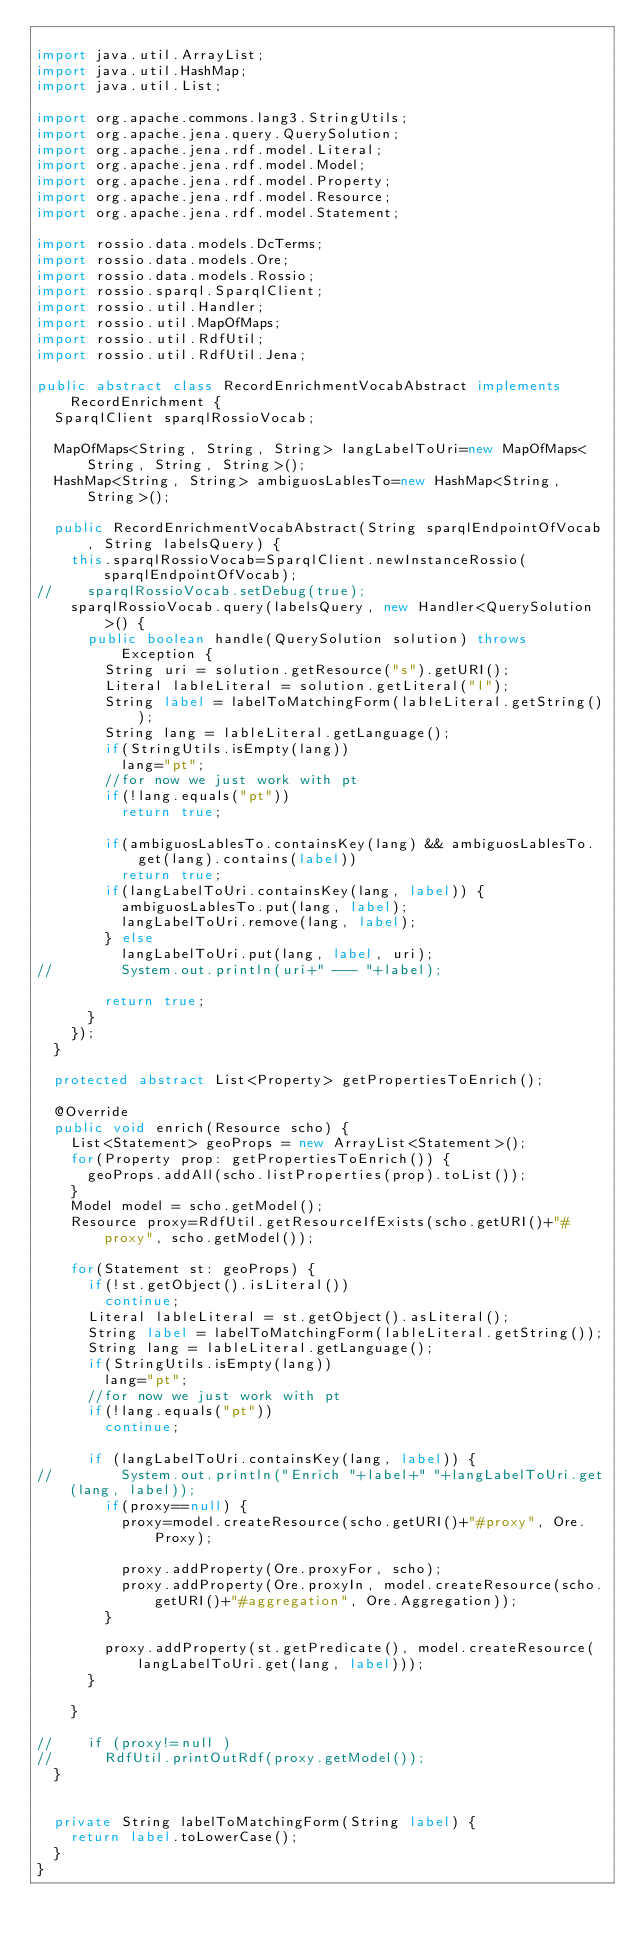<code> <loc_0><loc_0><loc_500><loc_500><_Java_>
import java.util.ArrayList;
import java.util.HashMap;
import java.util.List;

import org.apache.commons.lang3.StringUtils;
import org.apache.jena.query.QuerySolution;
import org.apache.jena.rdf.model.Literal;
import org.apache.jena.rdf.model.Model;
import org.apache.jena.rdf.model.Property;
import org.apache.jena.rdf.model.Resource;
import org.apache.jena.rdf.model.Statement;

import rossio.data.models.DcTerms;
import rossio.data.models.Ore;
import rossio.data.models.Rossio;
import rossio.sparql.SparqlClient;
import rossio.util.Handler;
import rossio.util.MapOfMaps;
import rossio.util.RdfUtil;
import rossio.util.RdfUtil.Jena;

public abstract class RecordEnrichmentVocabAbstract implements RecordEnrichment {
	SparqlClient sparqlRossioVocab;
	
	MapOfMaps<String, String, String> langLabelToUri=new MapOfMaps<String, String, String>();
	HashMap<String, String> ambiguosLablesTo=new HashMap<String, String>();
	
	public RecordEnrichmentVocabAbstract(String sparqlEndpointOfVocab, String labelsQuery) {
		this.sparqlRossioVocab=SparqlClient.newInstanceRossio(sparqlEndpointOfVocab);
//		sparqlRossioVocab.setDebug(true);
		sparqlRossioVocab.query(labelsQuery, new Handler<QuerySolution>() {
			public boolean handle(QuerySolution solution) throws Exception {
				String uri = solution.getResource("s").getURI();
				Literal lableLiteral = solution.getLiteral("l");
				String label = labelToMatchingForm(lableLiteral.getString());
				String lang = lableLiteral.getLanguage();
				if(StringUtils.isEmpty(lang))
					lang="pt";
				//for now we just work with pt
				if(!lang.equals("pt"))
					return true;
				
				if(ambiguosLablesTo.containsKey(lang) && ambiguosLablesTo.get(lang).contains(label))
					return true;
				if(langLabelToUri.containsKey(lang, label)) {
					ambiguosLablesTo.put(lang, label);
					langLabelToUri.remove(lang, label);
				} else
					langLabelToUri.put(lang, label, uri);
//				System.out.println(uri+" --- "+label);
				
				return true;
			}
		});
	}
	
	protected abstract List<Property> getPropertiesToEnrich();
	
	@Override
	public void enrich(Resource scho) {
		List<Statement> geoProps = new ArrayList<Statement>();
		for(Property prop: getPropertiesToEnrich()) {
			geoProps.addAll(scho.listProperties(prop).toList());			
		}
		Model model = scho.getModel();
		Resource proxy=RdfUtil.getResourceIfExists(scho.getURI()+"#proxy", scho.getModel());
		
		for(Statement st: geoProps) {
			if(!st.getObject().isLiteral())
				continue;
			Literal lableLiteral = st.getObject().asLiteral();
			String label = labelToMatchingForm(lableLiteral.getString());
			String lang = lableLiteral.getLanguage();
			if(StringUtils.isEmpty(lang))
				lang="pt";
			//for now we just work with pt
			if(!lang.equals("pt"))
				continue;
			
			if (langLabelToUri.containsKey(lang, label)) {
//				System.out.println("Enrich "+label+" "+langLabelToUri.get(lang, label));
				if(proxy==null) {
					proxy=model.createResource(scho.getURI()+"#proxy", Ore.Proxy);

					proxy.addProperty(Ore.proxyFor, scho);
					proxy.addProperty(Ore.proxyIn, model.createResource(scho.getURI()+"#aggregation", Ore.Aggregation));
				}
				
				proxy.addProperty(st.getPredicate(), model.createResource(langLabelToUri.get(lang, label)));
			}

		}
		
//		if (proxy!=null )
//			RdfUtil.printOutRdf(proxy.getModel());		
	}
	
	
	private String labelToMatchingForm(String label) {
		return label.toLowerCase();
	}
}
</code> 